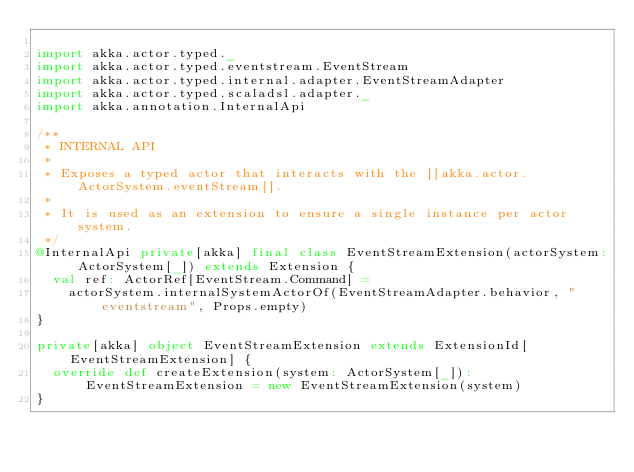<code> <loc_0><loc_0><loc_500><loc_500><_Scala_>
import akka.actor.typed._
import akka.actor.typed.eventstream.EventStream
import akka.actor.typed.internal.adapter.EventStreamAdapter
import akka.actor.typed.scaladsl.adapter._
import akka.annotation.InternalApi

/**
 * INTERNAL API
 *
 * Exposes a typed actor that interacts with the [[akka.actor.ActorSystem.eventStream]].
 *
 * It is used as an extension to ensure a single instance per actor system.
 */
@InternalApi private[akka] final class EventStreamExtension(actorSystem: ActorSystem[_]) extends Extension {
  val ref: ActorRef[EventStream.Command] =
    actorSystem.internalSystemActorOf(EventStreamAdapter.behavior, "eventstream", Props.empty)
}

private[akka] object EventStreamExtension extends ExtensionId[EventStreamExtension] {
  override def createExtension(system: ActorSystem[_]): EventStreamExtension = new EventStreamExtension(system)
}
</code> 